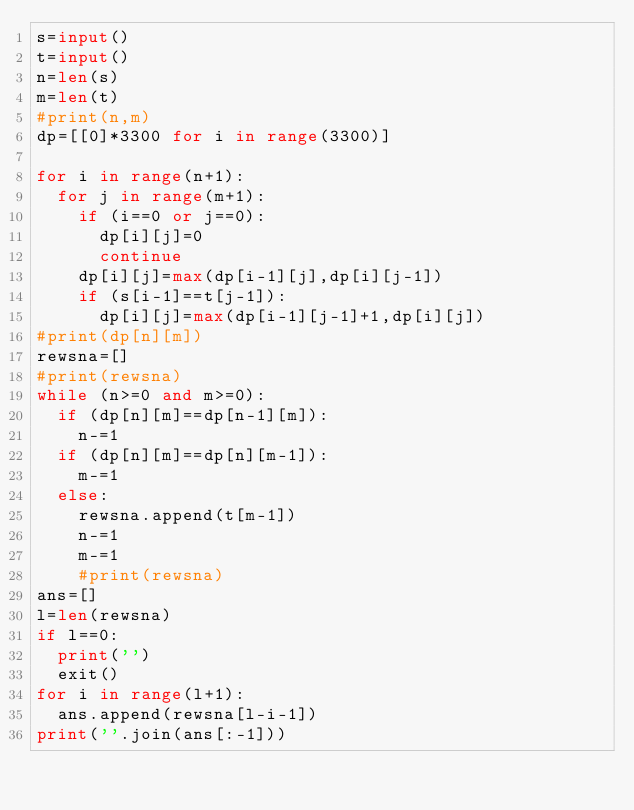<code> <loc_0><loc_0><loc_500><loc_500><_Python_>s=input()
t=input()
n=len(s)
m=len(t)
#print(n,m)
dp=[[0]*3300 for i in range(3300)]

for i in range(n+1):
  for j in range(m+1):
    if (i==0 or j==0):
      dp[i][j]=0
      continue
    dp[i][j]=max(dp[i-1][j],dp[i][j-1])
    if (s[i-1]==t[j-1]):
      dp[i][j]=max(dp[i-1][j-1]+1,dp[i][j])
#print(dp[n][m])  
rewsna=[]
#print(rewsna)
while (n>=0 and m>=0):
  if (dp[n][m]==dp[n-1][m]):
    n-=1
  if (dp[n][m]==dp[n][m-1]):
    m-=1
  else:
    rewsna.append(t[m-1])
    n-=1
    m-=1
    #print(rewsna)
ans=[] 
l=len(rewsna)
if l==0:
  print('')
  exit()
for i in range(l+1):
  ans.append(rewsna[l-i-1])
print(''.join(ans[:-1]))</code> 